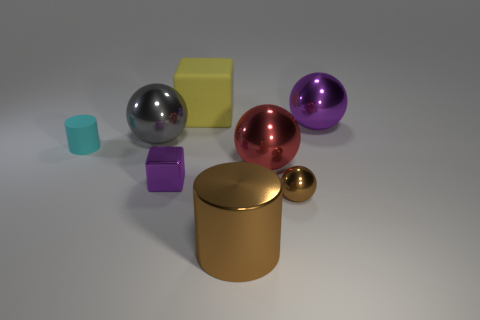There is a brown object on the left side of the small brown thing; is it the same shape as the red thing?
Offer a very short reply. No. How many small things are brown shiny cylinders or purple objects?
Offer a very short reply. 1. Is the number of small things on the left side of the tiny cyan object the same as the number of red metallic balls that are in front of the tiny purple object?
Ensure brevity in your answer.  Yes. What number of other objects are there of the same color as the tiny metallic cube?
Offer a very short reply. 1. Is the color of the large cylinder the same as the large thing that is on the right side of the brown ball?
Offer a very short reply. No. How many purple objects are big cubes or large objects?
Offer a very short reply. 1. Are there an equal number of yellow things that are on the right side of the purple metallic ball and big red metallic things?
Ensure brevity in your answer.  No. Is there anything else that is the same size as the cyan thing?
Make the answer very short. Yes. There is a tiny shiny thing that is the same shape as the large purple shiny thing; what color is it?
Your answer should be very brief. Brown. How many tiny purple things are the same shape as the big purple thing?
Provide a short and direct response. 0. 